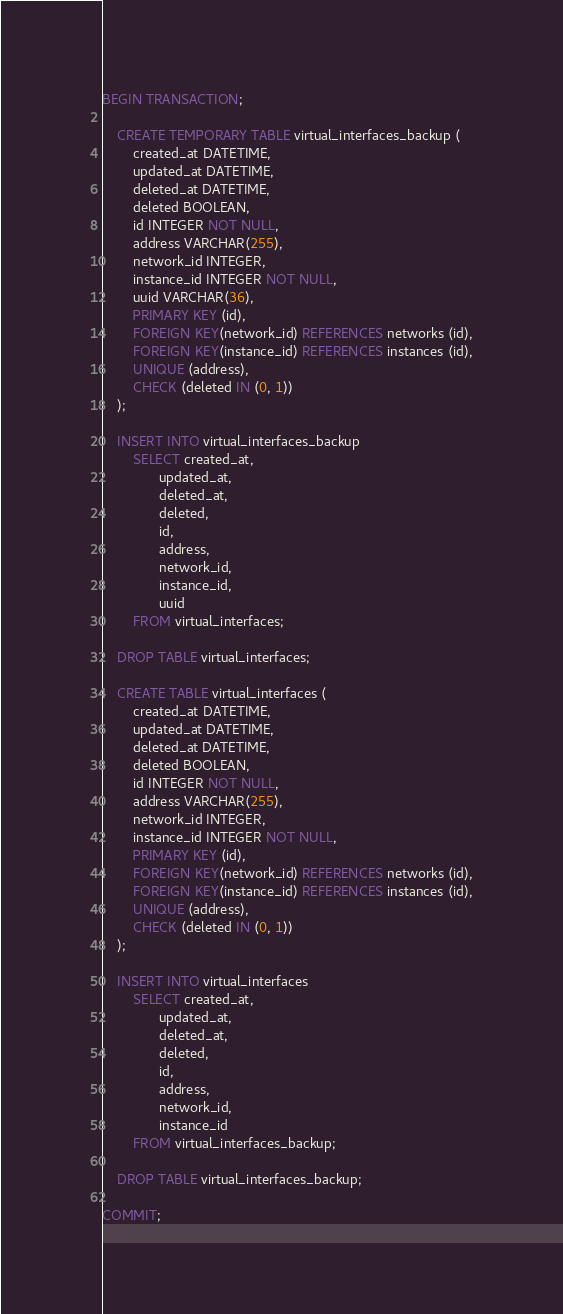Convert code to text. <code><loc_0><loc_0><loc_500><loc_500><_SQL_>BEGIN TRANSACTION;

    CREATE TEMPORARY TABLE virtual_interfaces_backup (
        created_at DATETIME,
        updated_at DATETIME,
        deleted_at DATETIME,
        deleted BOOLEAN,
        id INTEGER NOT NULL,
        address VARCHAR(255),
        network_id INTEGER,
        instance_id INTEGER NOT NULL,
        uuid VARCHAR(36),
        PRIMARY KEY (id),
        FOREIGN KEY(network_id) REFERENCES networks (id),
        FOREIGN KEY(instance_id) REFERENCES instances (id),
        UNIQUE (address),
        CHECK (deleted IN (0, 1))
    );

    INSERT INTO virtual_interfaces_backup
        SELECT created_at,
               updated_at,
               deleted_at,
               deleted,
               id,
               address,
               network_id,
               instance_id,
               uuid
        FROM virtual_interfaces;

    DROP TABLE virtual_interfaces;

    CREATE TABLE virtual_interfaces (
        created_at DATETIME,
        updated_at DATETIME,
        deleted_at DATETIME,
        deleted BOOLEAN,
        id INTEGER NOT NULL,
        address VARCHAR(255),
        network_id INTEGER,
        instance_id INTEGER NOT NULL,
        PRIMARY KEY (id),
        FOREIGN KEY(network_id) REFERENCES networks (id),
        FOREIGN KEY(instance_id) REFERENCES instances (id),
        UNIQUE (address),
        CHECK (deleted IN (0, 1))
    );

    INSERT INTO virtual_interfaces
        SELECT created_at,
               updated_at,
               deleted_at,
               deleted,
               id,
               address,
               network_id,
               instance_id
        FROM virtual_interfaces_backup;

    DROP TABLE virtual_interfaces_backup;

COMMIT;
</code> 